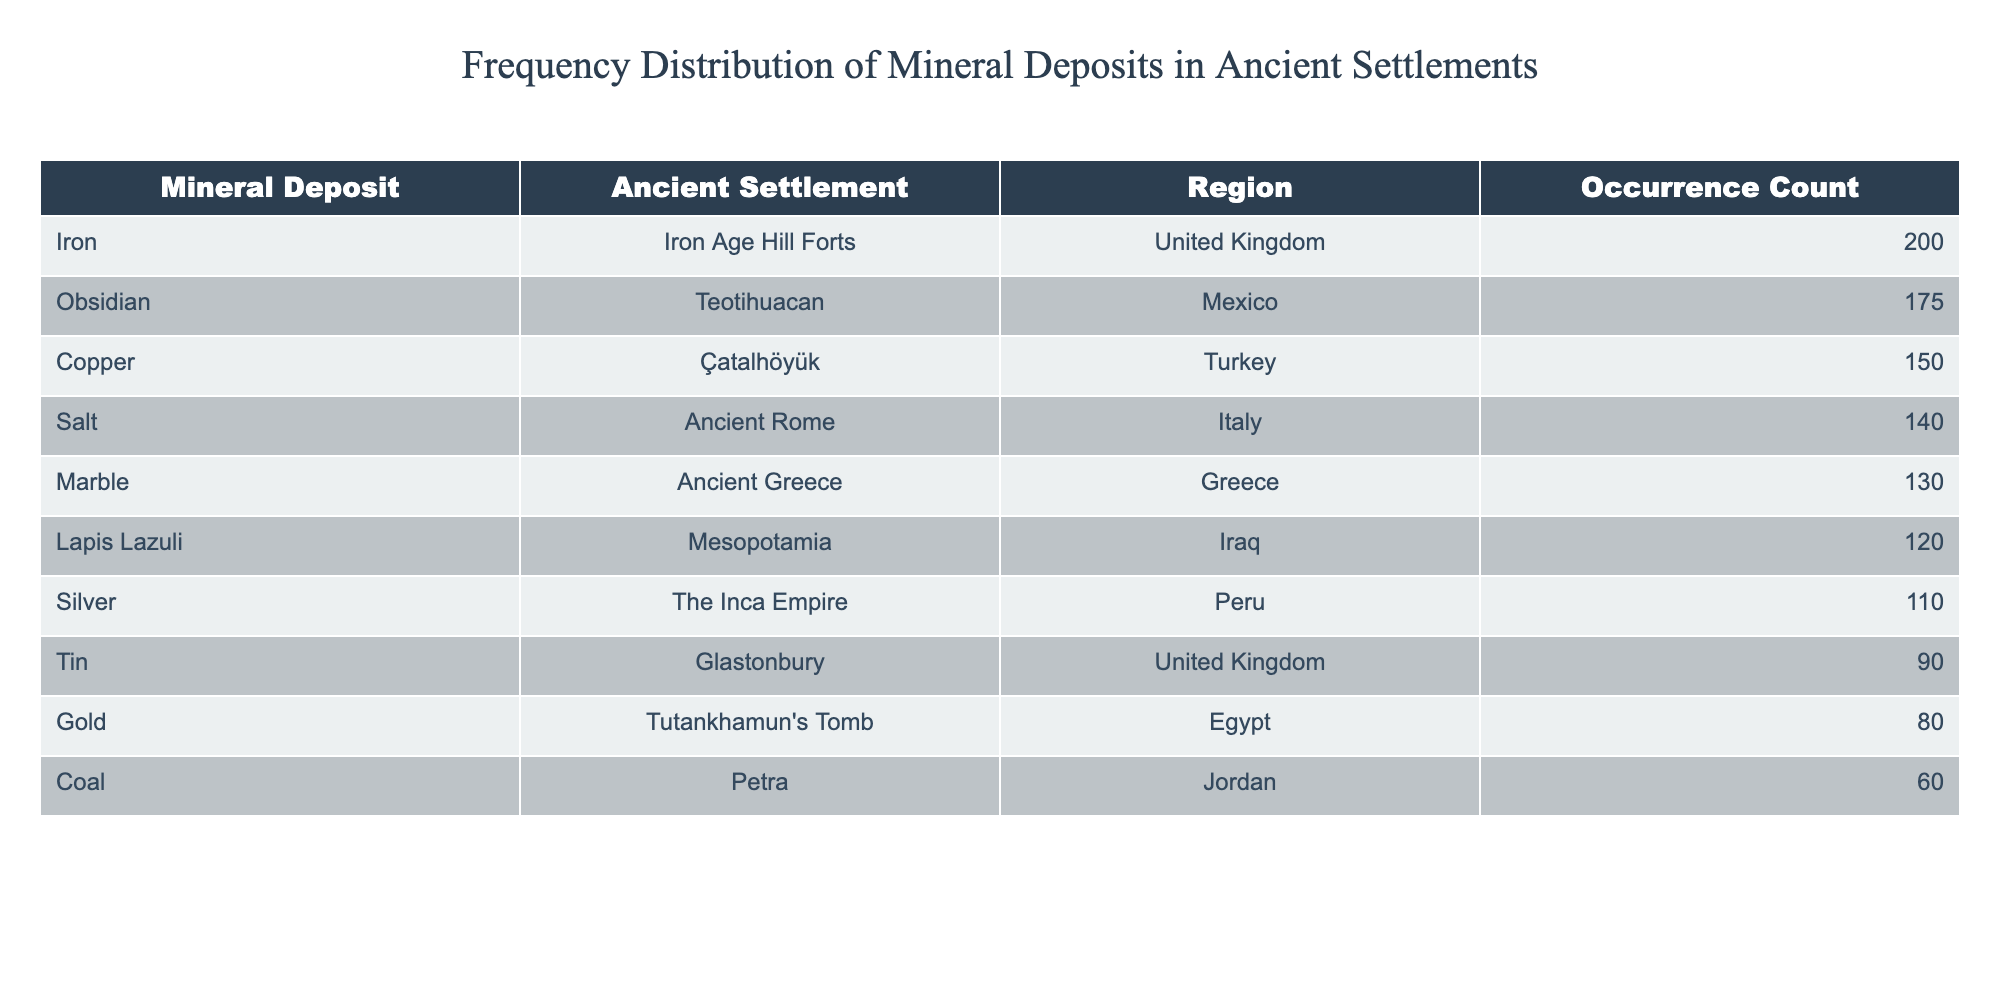What is the highest occurrence count of a mineral deposit linked to an ancient settlement? The highest value in the "Occurrence Count" column is found alongside the "Iron" mineral deposit linked to "Iron Age Hill Forts" in the United Kingdom, which has an occurrence count of 200.
Answer: 200 Which ancient settlement is associated with the mineral deposit "Lapis Lazuli"? The "Lapis Lazuli" mineral deposit is linked to the ancient settlement of "Mesopotamia" in Iraq, as listed in the table.
Answer: Mesopotamia What is the total occurrence count of mineral deposits from ancient settlements in the United Kingdom? To find the total, we sum the occurrence counts of the mineral deposits linked to settlements in the UK: 200 (Iron) + 90 (Tin) = 290.
Answer: 290 Is there a mineral deposit associated with the ancient settlement of Petra? Yes, the table shows that "Coal" is the mineral deposit linked to Petra, with an occurrence count of 60.
Answer: Yes What is the difference in occurrence counts between the minerals "Copper" and "Silver"? We subtract the occurrence count of "Silver" (110) from "Copper" (150): 150 - 110 = 40. This indicates that "Copper" has 40 more occurrences than "Silver".
Answer: 40 Which mineral deposit has an occurrence count closest to the average occurrence count? First, we calculate the average occurrence count by summing all occurrences (150 + 80 + 120 + 200 + 90 + 60 + 175 + 140 + 110 + 130 = 1,255) and dividing by the number of deposits (10), giving us an average of 125.5. The mineral closest to this average is "Marble" with an occurrence count of 130.
Answer: Marble Is there any mineral deposit linked to ancient Rome with an occurrence count of over 100? Yes, the table indicates that "Salt" is the mineral deposit linked to ancient Rome, with an occurrence count of 140, which is over 100.
Answer: Yes What is the total occurrence count of minerals associated with settlements in Egypt? The only mineral linked to Egypt in the table is "Gold," which has an occurrence count of 80. Therefore, the total occurrence count is simply 80.
Answer: 80 Which mineral deposit has the second-highest occurrence count, and what is that count? The mineral deposit with the second-highest occurrence count is "Obsidian," linked to Teotihuacan in Mexico, with a count of 175, which is less than the highest (200 for Iron) but more than any other deposit.
Answer: 175 